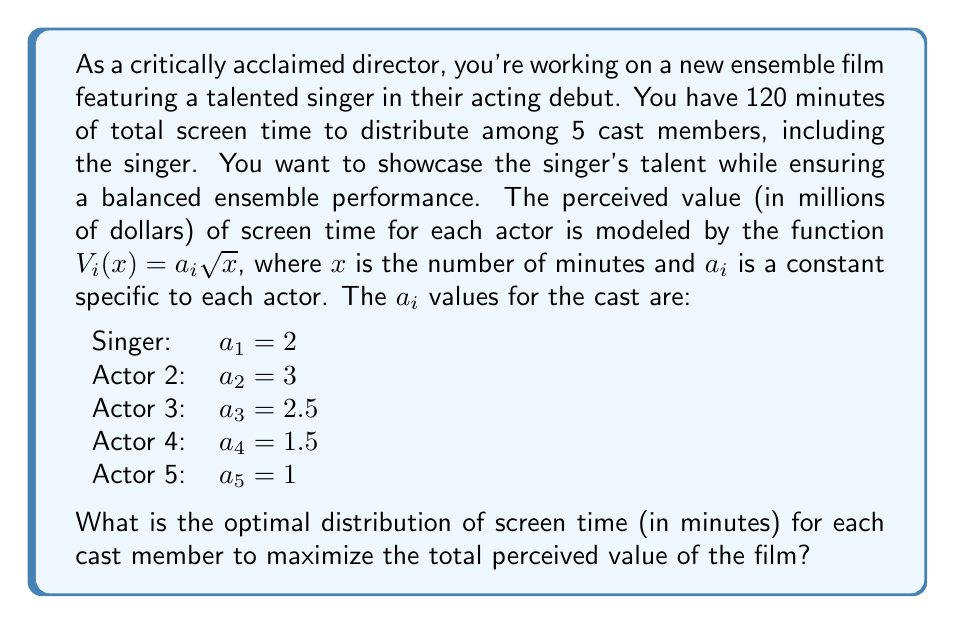Give your solution to this math problem. To solve this problem, we'll use the method of Lagrange multipliers, which is ideal for optimizing constrained problems in game theory.

1) Let $x_i$ represent the screen time for each actor. Our objective function is:

   $$V = 2\sqrt{x_1} + 3\sqrt{x_2} + 2.5\sqrt{x_3} + 1.5\sqrt{x_4} + \sqrt{x_5}$$

2) Our constraint is:

   $$x_1 + x_2 + x_3 + x_4 + x_5 = 120$$

3) We form the Lagrangian:

   $$L = 2\sqrt{x_1} + 3\sqrt{x_2} + 2.5\sqrt{x_3} + 1.5\sqrt{x_4} + \sqrt{x_5} - \lambda(x_1 + x_2 + x_3 + x_4 + x_5 - 120)$$

4) We take partial derivatives and set them equal to zero:

   $$\frac{\partial L}{\partial x_1} = \frac{1}{\sqrt{x_1}} - \lambda = 0$$
   $$\frac{\partial L}{\partial x_2} = \frac{3}{2\sqrt{x_2}} - \lambda = 0$$
   $$\frac{\partial L}{\partial x_3} = \frac{5}{4\sqrt{x_3}} - \lambda = 0$$
   $$\frac{\partial L}{\partial x_4} = \frac{3}{4\sqrt{x_4}} - \lambda = 0$$
   $$\frac{\partial L}{\partial x_5} = \frac{1}{2\sqrt{x_5}} - \lambda = 0$$

5) From these equations, we can derive:

   $$x_1 = \frac{4}{\lambda^2}, x_2 = \frac{9}{\lambda^2}, x_3 = \frac{25}{4\lambda^2}, x_4 = \frac{9}{4\lambda^2}, x_5 = \frac{1}{\lambda^2}$$

6) Substituting these into our constraint equation:

   $$\frac{4}{\lambda^2} + \frac{9}{\lambda^2} + \frac{25}{4\lambda^2} + \frac{9}{4\lambda^2} + \frac{1}{\lambda^2} = 120$$

7) Simplifying:

   $$\frac{73}{\lambda^2} = 120$$
   $$\lambda^2 = \frac{73}{120}$$
   $$\lambda = \sqrt{\frac{73}{120}} \approx 0.7794$$

8) Now we can calculate each $x_i$:

   $$x_1 = \frac{4}{(0.7794)^2} \approx 6.58 \times 4 \approx 26.32$$
   $$x_2 = \frac{9}{(0.7794)^2} \approx 6.58 \times 9 \approx 59.22$$
   $$x_3 = \frac{25}{4(0.7794)^2} \approx 6.58 \times 6.25 \approx 41.13$$
   $$x_4 = \frac{9}{4(0.7794)^2} \approx 6.58 \times 2.25 \approx 14.81$$
   $$x_5 = \frac{1}{(0.7794)^2} \approx 6.58 \times 1 \approx 6.58$$

9) Rounding to the nearest minute (as screen time is typically measured in whole minutes):

   Singer (x1): 26 minutes
   Actor 2 (x2): 59 minutes
   Actor 3 (x3): 41 minutes
   Actor 4 (x4): 15 minutes
   Actor 5 (x5): 7 minutes
Answer: The optimal distribution of screen time (in minutes) for each cast member is:
Singer: 26 minutes
Actor 2: 59 minutes
Actor 3: 41 minutes
Actor 4: 15 minutes
Actor 5: 7 minutes 